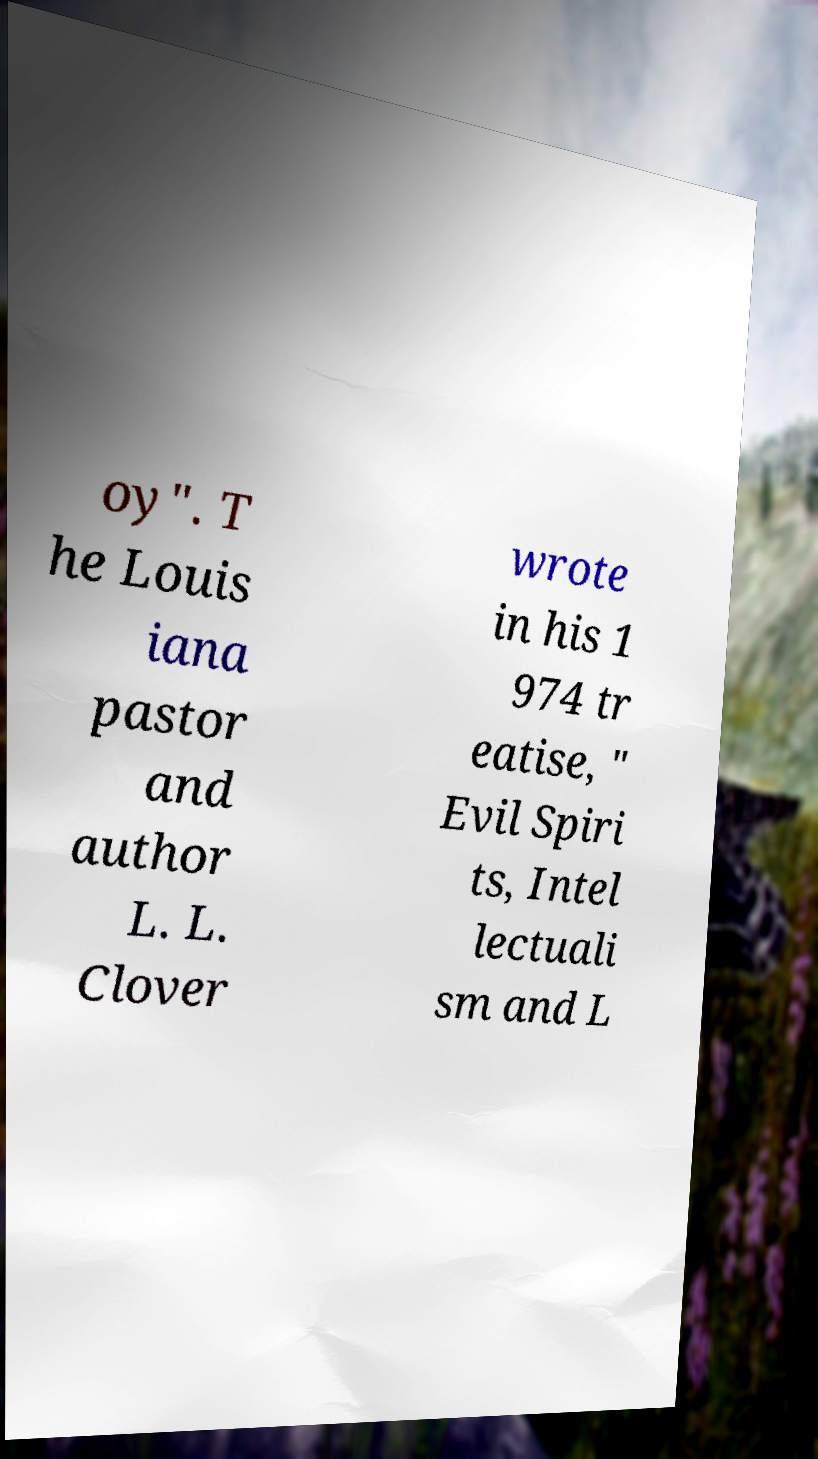I need the written content from this picture converted into text. Can you do that? oy". T he Louis iana pastor and author L. L. Clover wrote in his 1 974 tr eatise, " Evil Spiri ts, Intel lectuali sm and L 